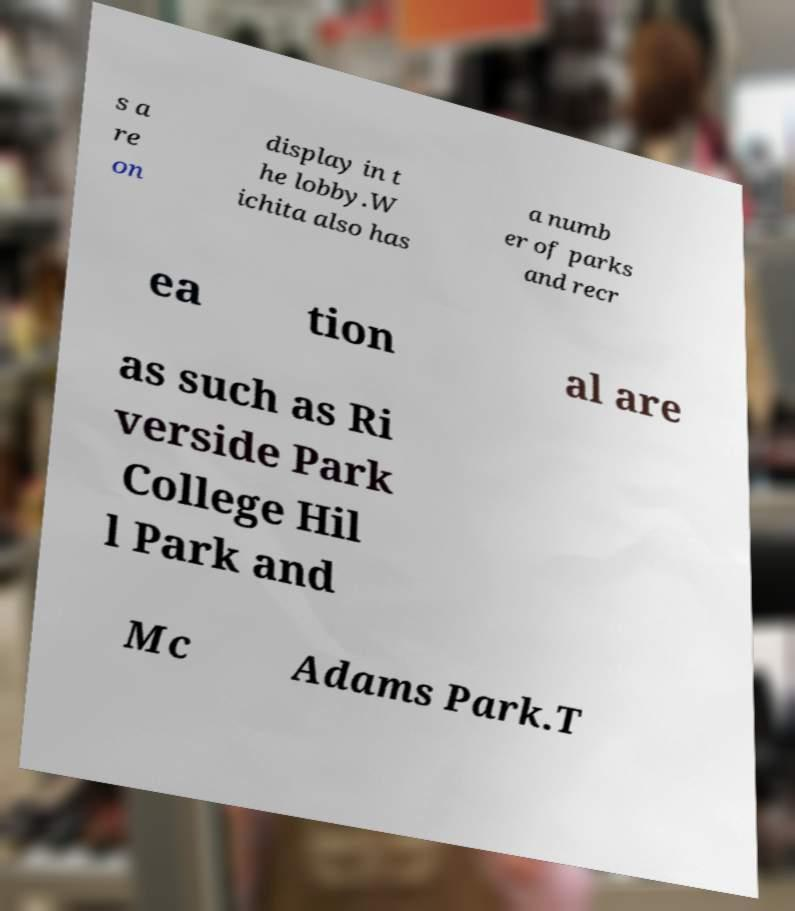Please identify and transcribe the text found in this image. s a re on display in t he lobby.W ichita also has a numb er of parks and recr ea tion al are as such as Ri verside Park College Hil l Park and Mc Adams Park.T 